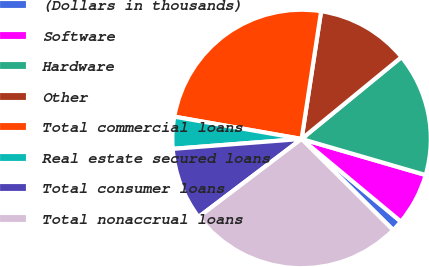Convert chart to OTSL. <chart><loc_0><loc_0><loc_500><loc_500><pie_chart><fcel>(Dollars in thousands)<fcel>Software<fcel>Hardware<fcel>Other<fcel>Total commercial loans<fcel>Real estate secured loans<fcel>Total consumer loans<fcel>Total nonaccrual loans<nl><fcel>1.42%<fcel>6.54%<fcel>15.43%<fcel>11.66%<fcel>24.66%<fcel>3.98%<fcel>9.1%<fcel>27.22%<nl></chart> 